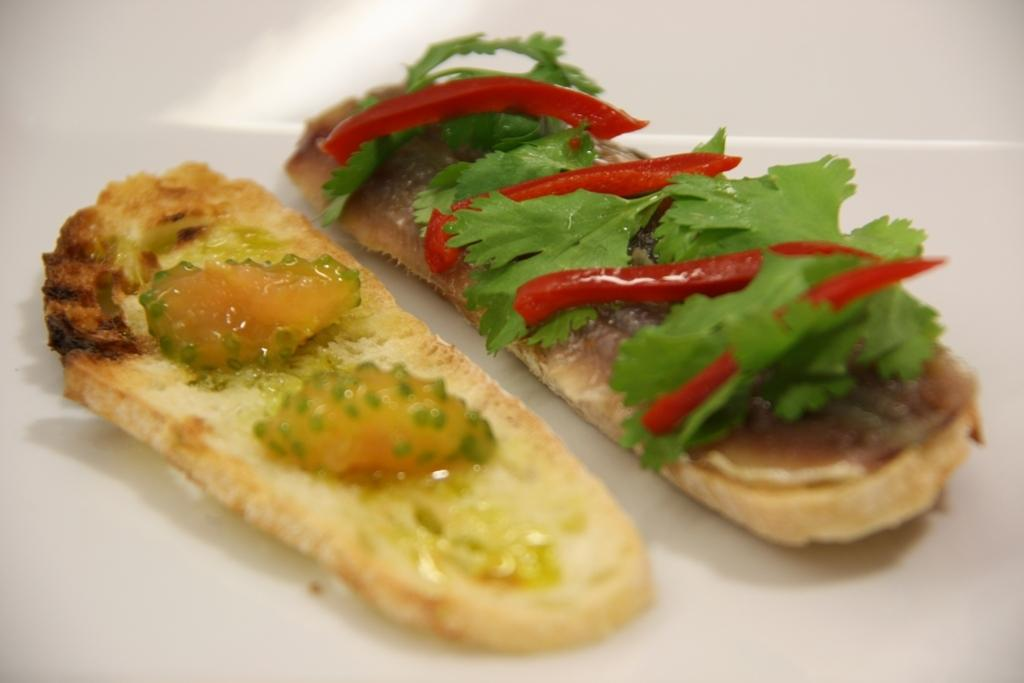What type of food item is visible in the image? There is a food item in the image, but the specific type cannot be determined from the provided facts. What herb is present on the food item? Coriander leaves are present on the food item. What spice is present on the food item? Chillies are present on the food item. How many threads are used to sew the bird in the image? There is no bird or thread present in the image; it features a food item with coriander leaves and chillies. 